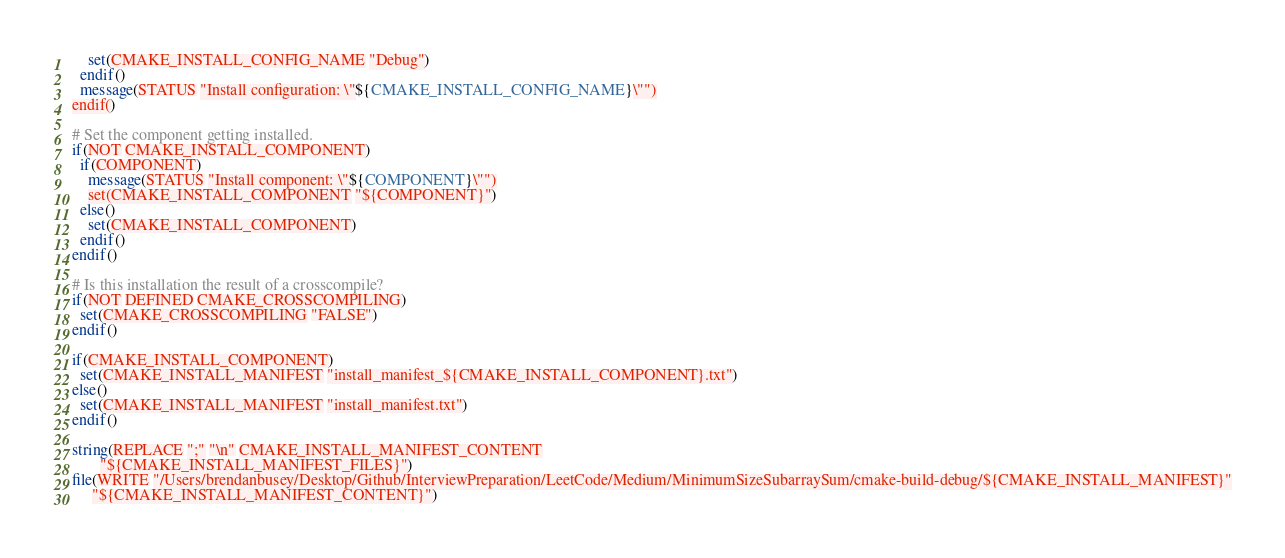Convert code to text. <code><loc_0><loc_0><loc_500><loc_500><_CMake_>    set(CMAKE_INSTALL_CONFIG_NAME "Debug")
  endif()
  message(STATUS "Install configuration: \"${CMAKE_INSTALL_CONFIG_NAME}\"")
endif()

# Set the component getting installed.
if(NOT CMAKE_INSTALL_COMPONENT)
  if(COMPONENT)
    message(STATUS "Install component: \"${COMPONENT}\"")
    set(CMAKE_INSTALL_COMPONENT "${COMPONENT}")
  else()
    set(CMAKE_INSTALL_COMPONENT)
  endif()
endif()

# Is this installation the result of a crosscompile?
if(NOT DEFINED CMAKE_CROSSCOMPILING)
  set(CMAKE_CROSSCOMPILING "FALSE")
endif()

if(CMAKE_INSTALL_COMPONENT)
  set(CMAKE_INSTALL_MANIFEST "install_manifest_${CMAKE_INSTALL_COMPONENT}.txt")
else()
  set(CMAKE_INSTALL_MANIFEST "install_manifest.txt")
endif()

string(REPLACE ";" "\n" CMAKE_INSTALL_MANIFEST_CONTENT
       "${CMAKE_INSTALL_MANIFEST_FILES}")
file(WRITE "/Users/brendanbusey/Desktop/Github/InterviewPreparation/LeetCode/Medium/MinimumSizeSubarraySum/cmake-build-debug/${CMAKE_INSTALL_MANIFEST}"
     "${CMAKE_INSTALL_MANIFEST_CONTENT}")
</code> 